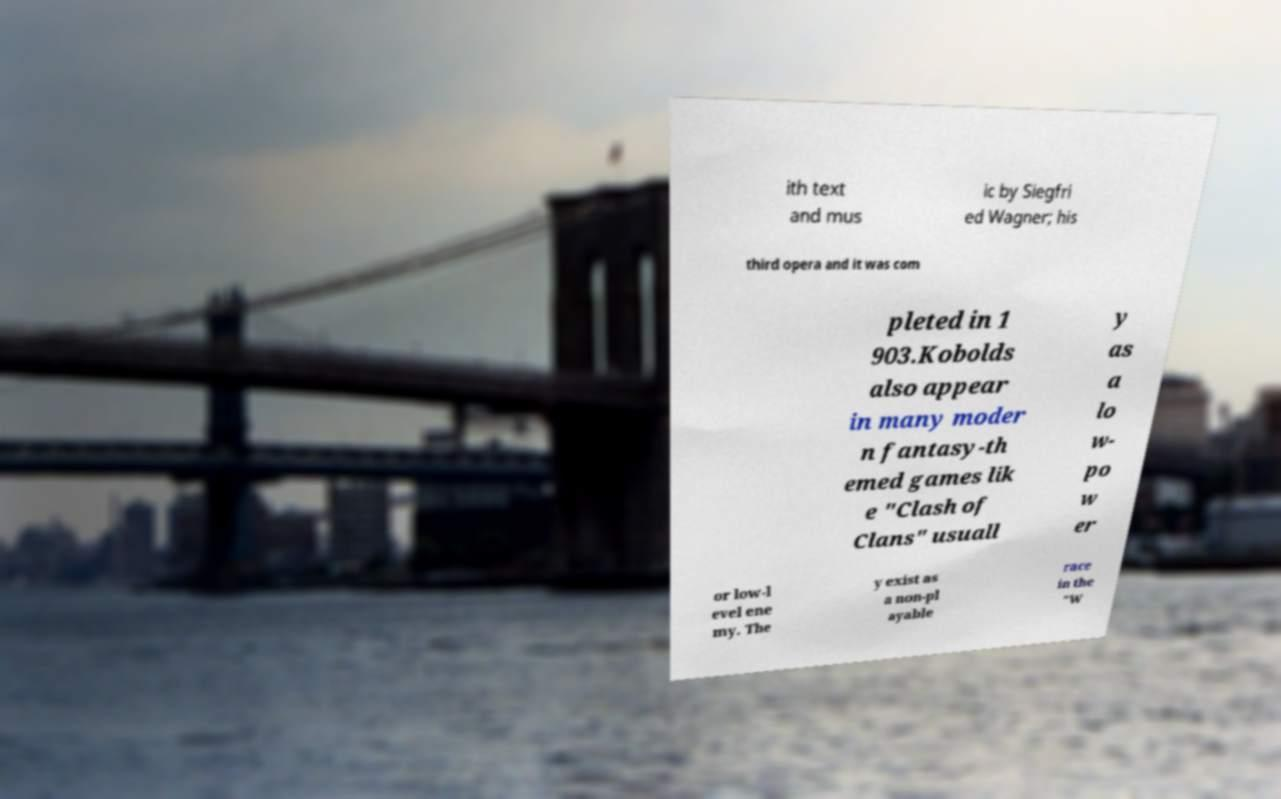Can you read and provide the text displayed in the image?This photo seems to have some interesting text. Can you extract and type it out for me? ith text and mus ic by Siegfri ed Wagner; his third opera and it was com pleted in 1 903.Kobolds also appear in many moder n fantasy-th emed games lik e "Clash of Clans" usuall y as a lo w- po w er or low-l evel ene my. The y exist as a non-pl ayable race in the "W 